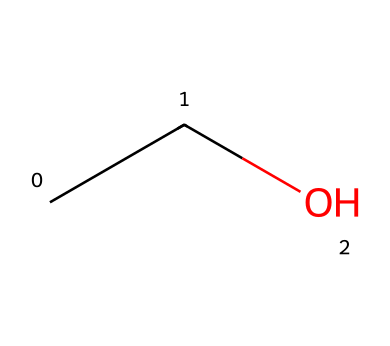What is the molecular formula of this chemical? The SMILES representation "CCO" indicates that there are two carbon atoms, five hydrogen atoms, and one oxygen atom. Therefore, the molecular formula can be derived as C2H6O.
Answer: C2H6O How many carbon atoms are present in this structure? The SMILES notation "CCO" shows that there are two 'C' characters, which indicate the presence of two carbon atoms in the structure.
Answer: 2 What functional group is present in ethanol? The structure indicates the presence of a hydroxyl (-OH) group attached to one of the carbon atoms, which is characteristic of alcohols.
Answer: hydroxyl group What is the type of this solvent? Ethanol is classified as an alcoholic solvent due to the presence of the hydroxyl functional group (-OH) and its ability to dissolve various polar and nonpolar substances.
Answer: alcoholic What is the total number of hydrogen atoms in this molecule? In the SMILES representation "CCO", the two carbon atoms are each bonded to three and two hydrogen atoms respectively, totaling five hydrogen atoms.
Answer: 6 What is the importance of ethanol in Japanese sake? Ethanol is the primary alcohol produced during fermentation in sake brewing, contributing to its flavor, aroma, and effect.
Answer: primary alcohol 